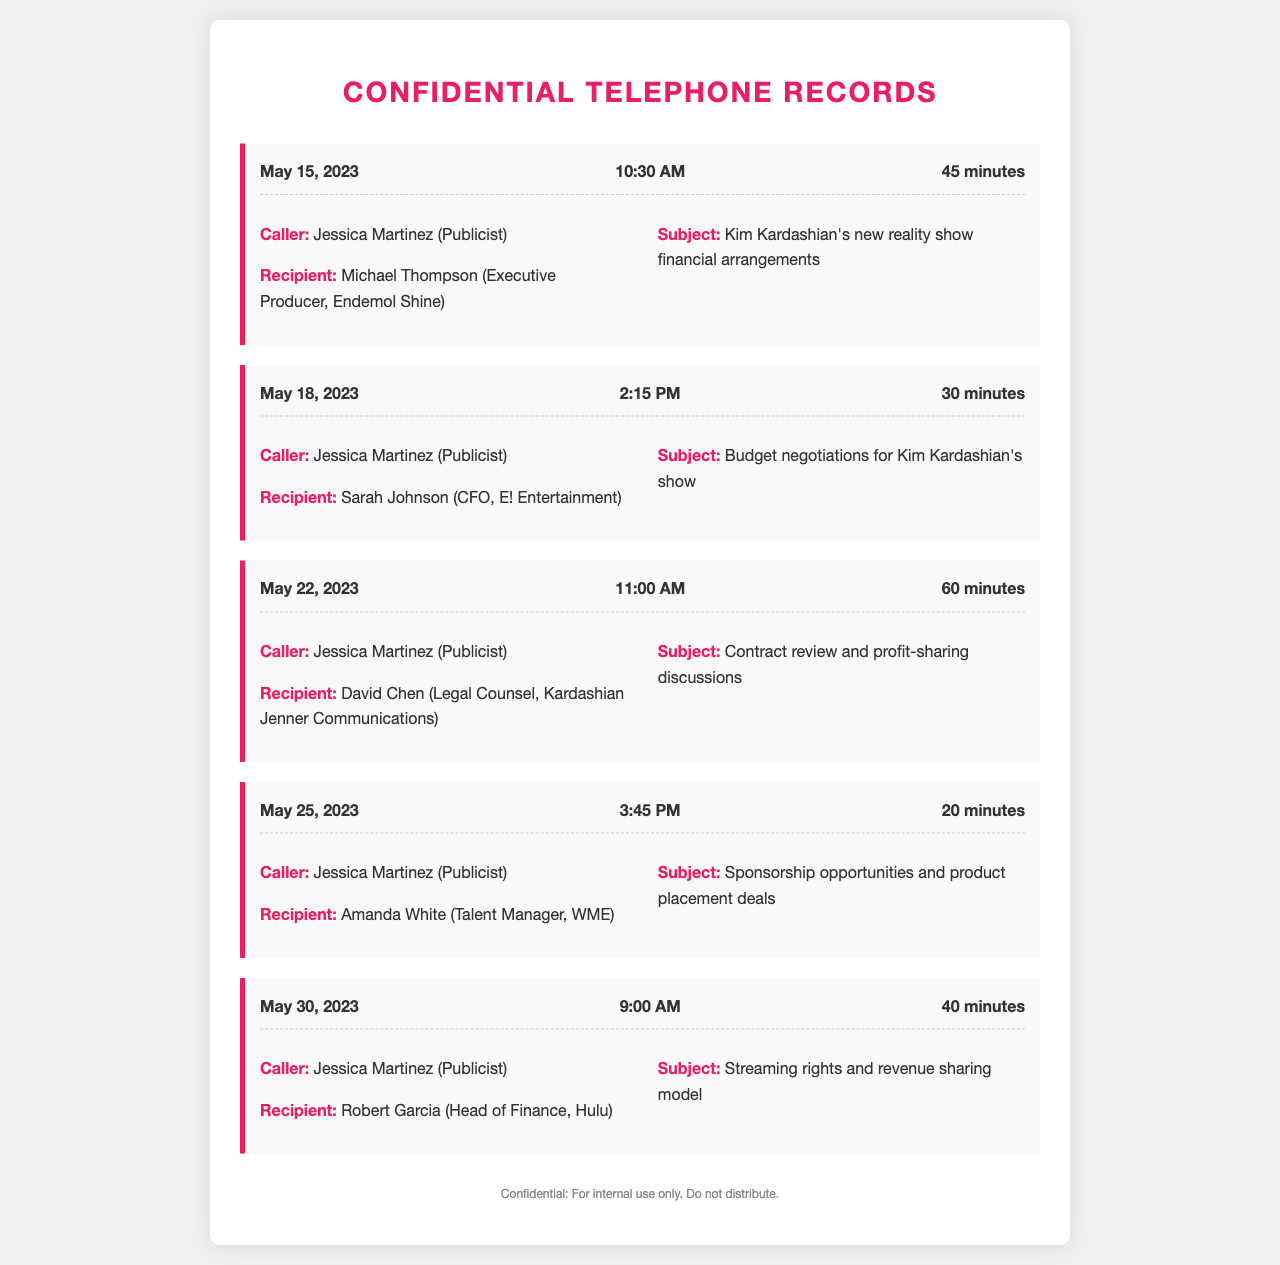What is the date of the call with Michael Thompson? The date can be found in the first record of the document, where it states May 15, 2023.
Answer: May 15, 2023 Who was the recipient of the call on May 18, 2023? The recipient is listed in the second record, which states Sarah Johnson (CFO, E! Entertainment).
Answer: Sarah Johnson What was the subject of Jessica's call to David Chen? The subject is detailed in the third record, which mentions contract review and profit-sharing discussions.
Answer: Contract review and profit-sharing discussions How long was the call on May 25, 2023? The duration of the call is specified in the fourth record as 20 minutes.
Answer: 20 minutes Which production company was involved in the discussion about sponsorship opportunities? This can be found in the fourth record mentioning Amanda White (Talent Manager, WME).
Answer: WME What is the financial role of Robert Garcia in the call on May 30, 2023? The role is provided in the fifth record, stating he is the Head of Finance at Hulu.
Answer: Head of Finance What was discussed in the call with Sarah Johnson? The discussion content is presented in the second record, which is budget negotiations for Kim Kardashian's show.
Answer: Budget negotiations for Kim Kardashian's show Which company was represented by David Chen? The representation is noted in the third record, stating Kardashian Jenner Communications.
Answer: Kardashian Jenner Communications How many calls were recorded in total? The total number of records can be counted from the document, which shows five individual calls were made.
Answer: Five 